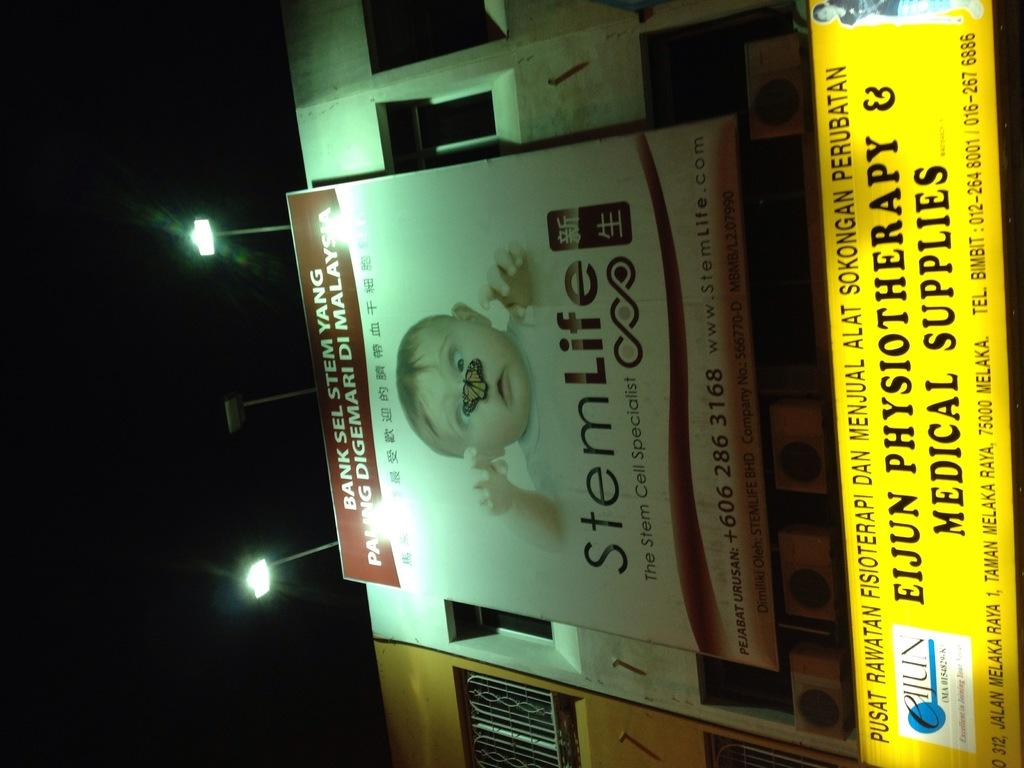Provide a one-sentence caption for the provided image. A billboard for StemLife pictures a baby with a butterfly on it's nose to advertise service for stem cells. 